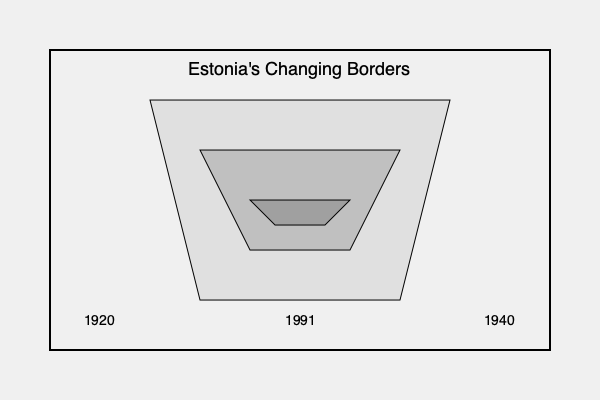In your graphic novel about Estonia's historical events, you need to create a series of map overlays showing the changing borders of Estonia. Which historical periods should be represented to accurately depict the most significant territorial changes, and how would you visually distinguish between these periods? To accurately represent the changing borders of Estonia throughout history using a series of map overlays, consider the following key periods and visual distinctions:

1. Pre-independence (before 1918):
   - Depict Estonia as part of the Russian Empire
   - Use a light shade or pattern to show the approximate area of Estonian-speaking regions

2. First period of independence (1918-1940):
   - Show the borders established after the Estonian War of Independence
   - Include the Tartu Peace Treaty borders of 1920
   - Use a distinct color or pattern to highlight this period of sovereignty

3. Soviet occupation (1940-1991):
   - Represent Estonia as part of the Soviet Union
   - Show the loss of territory to Russia (Petseri County and areas east of the Narva River)
   - Use a different color or pattern to indicate the Soviet period

4. Restored independence (1991-present):
   - Display the current borders of Estonia
   - Highlight the slight differences from the pre-1940 borders
   - Use the most prominent color or pattern to emphasize the current state

Visual distinctions:
- Use a gradient of colors or patterns to show the progression of time
- Employ different line styles (e.g., solid, dashed, dotted) for borders from different periods
- Add labels or a legend to clearly identify each period
- Consider using small icons or symbols to represent key historical events associated with border changes

By incorporating these elements, your graphic novel can effectively illustrate the territorial evolution of Estonia, providing readers with a clear visual understanding of the country's changing borders throughout its history.
Answer: 1918-1940, 1940-1991, 1991-present; use distinct colors, patterns, and line styles for each period. 